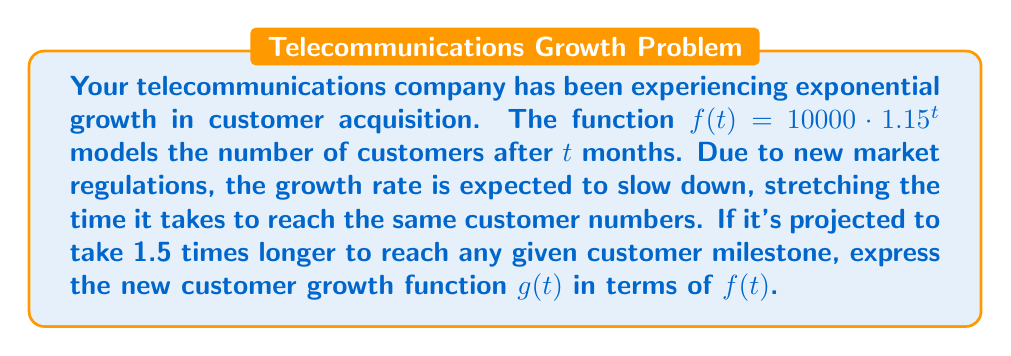Can you answer this question? To solve this problem, we need to apply a horizontal stretch to the original function $f(t)$. The stretch factor is 1.5, meaning it takes 1.5 times longer to reach the same y-value (number of customers).

Step 1: Identify the general form of a horizontal stretch.
For a function $f(t)$, a horizontal stretch by a factor of $k$ is represented as:
$g(t) = f(\frac{t}{k})$

Step 2: Apply the stretch factor to our specific case.
In this problem, $k = 1.5$. Therefore, the new function $g(t)$ is:

$g(t) = f(\frac{t}{1.5})$

Step 3: Express $g(t)$ in terms of the original function $f(t)$.
$g(t) = f(\frac{t}{1.5})$

This means that to find the number of customers at time $t$ in the new, slower growth model, we input $\frac{t}{1.5}$ into the original function $f$.
Answer: $g(t) = f(\frac{t}{1.5})$ 